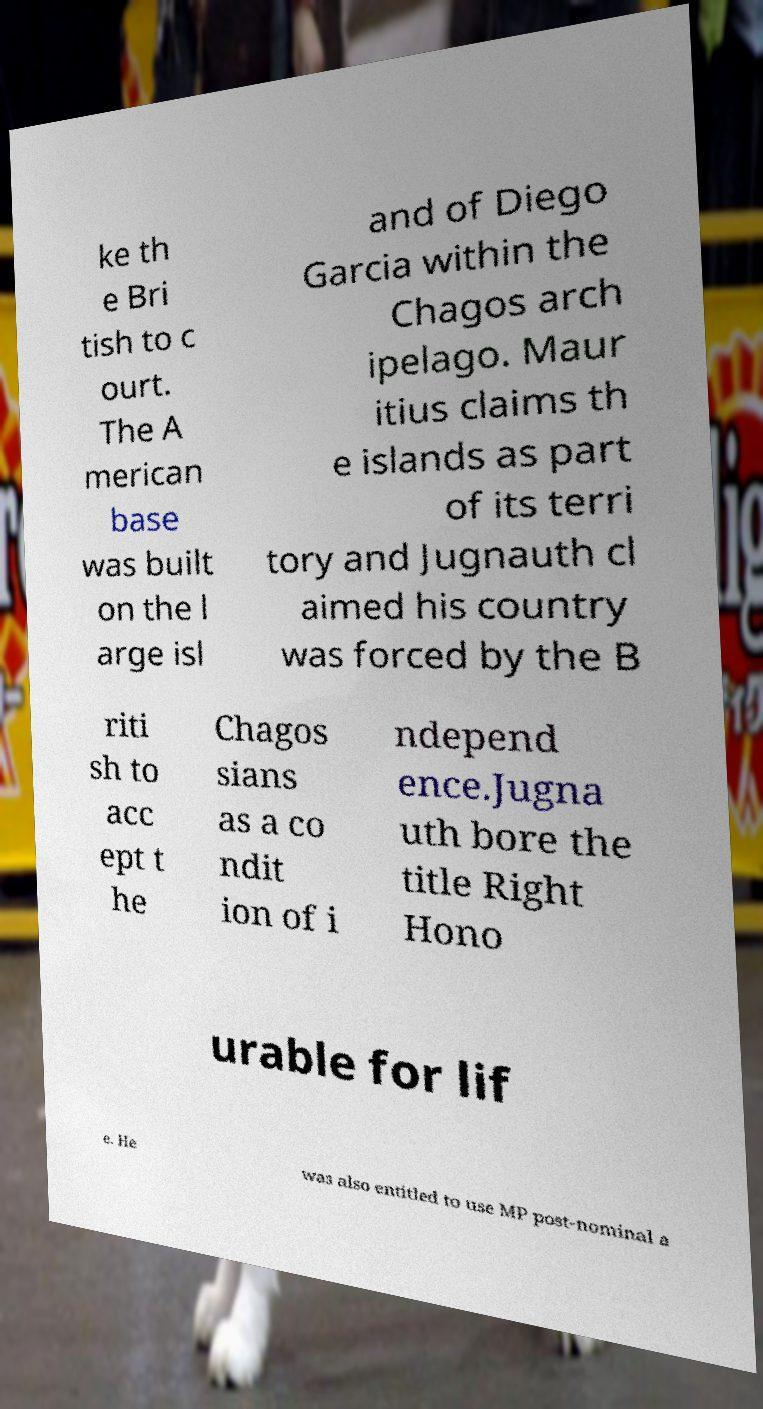Please read and relay the text visible in this image. What does it say? ke th e Bri tish to c ourt. The A merican base was built on the l arge isl and of Diego Garcia within the Chagos arch ipelago. Maur itius claims th e islands as part of its terri tory and Jugnauth cl aimed his country was forced by the B riti sh to acc ept t he Chagos sians as a co ndit ion of i ndepend ence.Jugna uth bore the title Right Hono urable for lif e. He was also entitled to use MP post-nominal a 